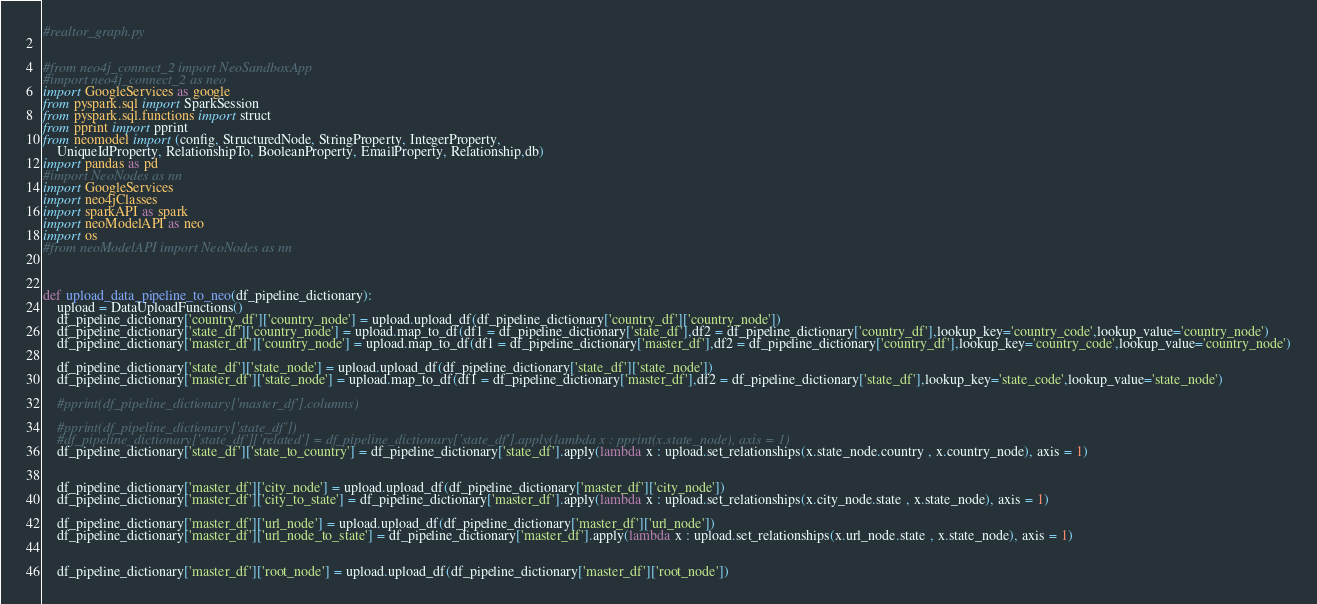Convert code to text. <code><loc_0><loc_0><loc_500><loc_500><_Python_>#realtor_graph.py


#from neo4j_connect_2 import NeoSandboxApp
#import neo4j_connect_2 as neo
import GoogleServices as google
from pyspark.sql import SparkSession
from pyspark.sql.functions import struct
from pprint import pprint
from neomodel import (config, StructuredNode, StringProperty, IntegerProperty,
    UniqueIdProperty, RelationshipTo, BooleanProperty, EmailProperty, Relationship,db)
import pandas as pd
#import NeoNodes as nn
import GoogleServices
import neo4jClasses
import sparkAPI as spark
import neoModelAPI as neo
import os
#from neoModelAPI import NeoNodes as nn



def upload_data_pipeline_to_neo(df_pipeline_dictionary):
    upload = DataUploadFunctions()
    df_pipeline_dictionary['country_df']['country_node'] = upload.upload_df(df_pipeline_dictionary['country_df']['country_node'])
    df_pipeline_dictionary['state_df']['country_node'] = upload.map_to_df(df1 = df_pipeline_dictionary['state_df'],df2 = df_pipeline_dictionary['country_df'],lookup_key='country_code',lookup_value='country_node')
    df_pipeline_dictionary['master_df']['country_node'] = upload.map_to_df(df1 = df_pipeline_dictionary['master_df'],df2 = df_pipeline_dictionary['country_df'],lookup_key='country_code',lookup_value='country_node')

    df_pipeline_dictionary['state_df']['state_node'] = upload.upload_df(df_pipeline_dictionary['state_df']['state_node'])
    df_pipeline_dictionary['master_df']['state_node'] = upload.map_to_df(df1 = df_pipeline_dictionary['master_df'],df2 = df_pipeline_dictionary['state_df'],lookup_key='state_code',lookup_value='state_node')
   
    #pprint(df_pipeline_dictionary['master_df'].columns)

    #pprint(df_pipeline_dictionary['state_df'])
    #df_pipeline_dictionary['state_df']['related'] = df_pipeline_dictionary['state_df'].apply(lambda x : pprint(x.state_node), axis = 1)
    df_pipeline_dictionary['state_df']['state_to_country'] = df_pipeline_dictionary['state_df'].apply(lambda x : upload.set_relationships(x.state_node.country , x.country_node), axis = 1)


    df_pipeline_dictionary['master_df']['city_node'] = upload.upload_df(df_pipeline_dictionary['master_df']['city_node'])
    df_pipeline_dictionary['master_df']['city_to_state'] = df_pipeline_dictionary['master_df'].apply(lambda x : upload.set_relationships(x.city_node.state , x.state_node), axis = 1)

    df_pipeline_dictionary['master_df']['url_node'] = upload.upload_df(df_pipeline_dictionary['master_df']['url_node'])
    df_pipeline_dictionary['master_df']['url_node_to_state'] = df_pipeline_dictionary['master_df'].apply(lambda x : upload.set_relationships(x.url_node.state , x.state_node), axis = 1)


    df_pipeline_dictionary['master_df']['root_node'] = upload.upload_df(df_pipeline_dictionary['master_df']['root_node'])</code> 